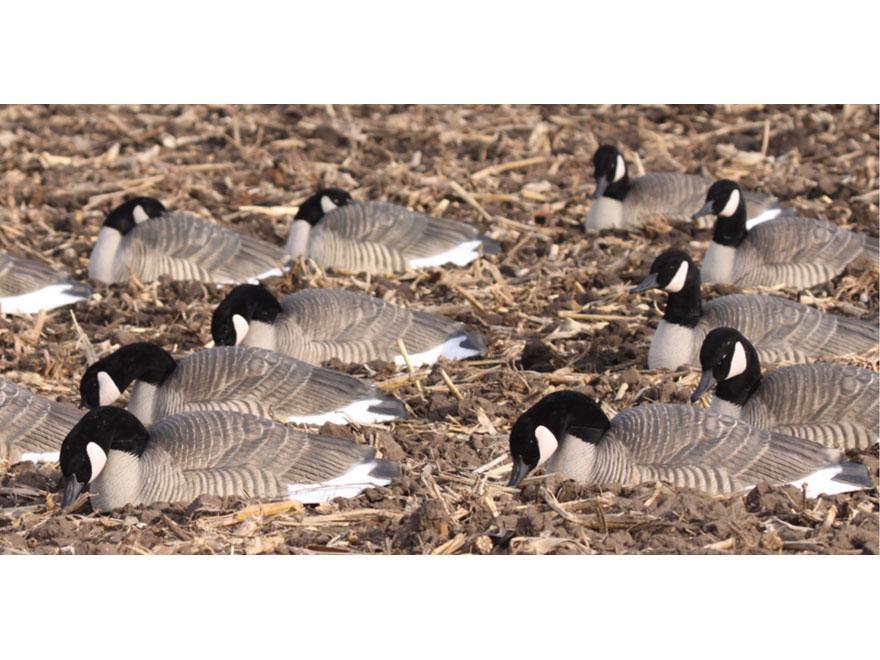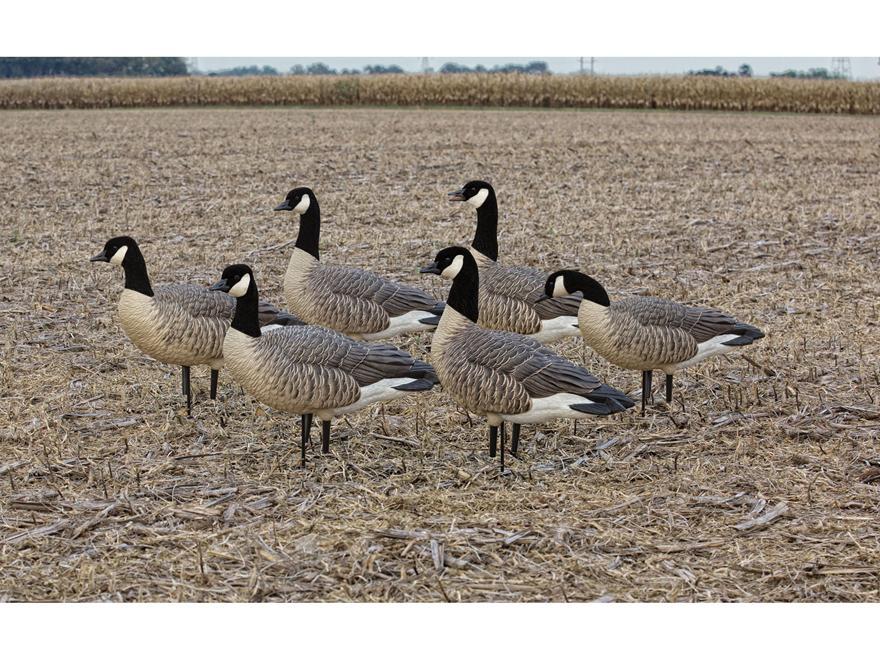The first image is the image on the left, the second image is the image on the right. For the images displayed, is the sentence "There are 18 or more Canadian Geese in open fields." factually correct? Answer yes or no. Yes. 